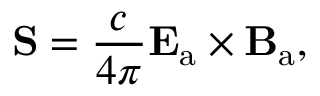<formula> <loc_0><loc_0><loc_500><loc_500>S = { \frac { c } { 4 \pi } } E _ { a } \times B _ { a } ,</formula> 